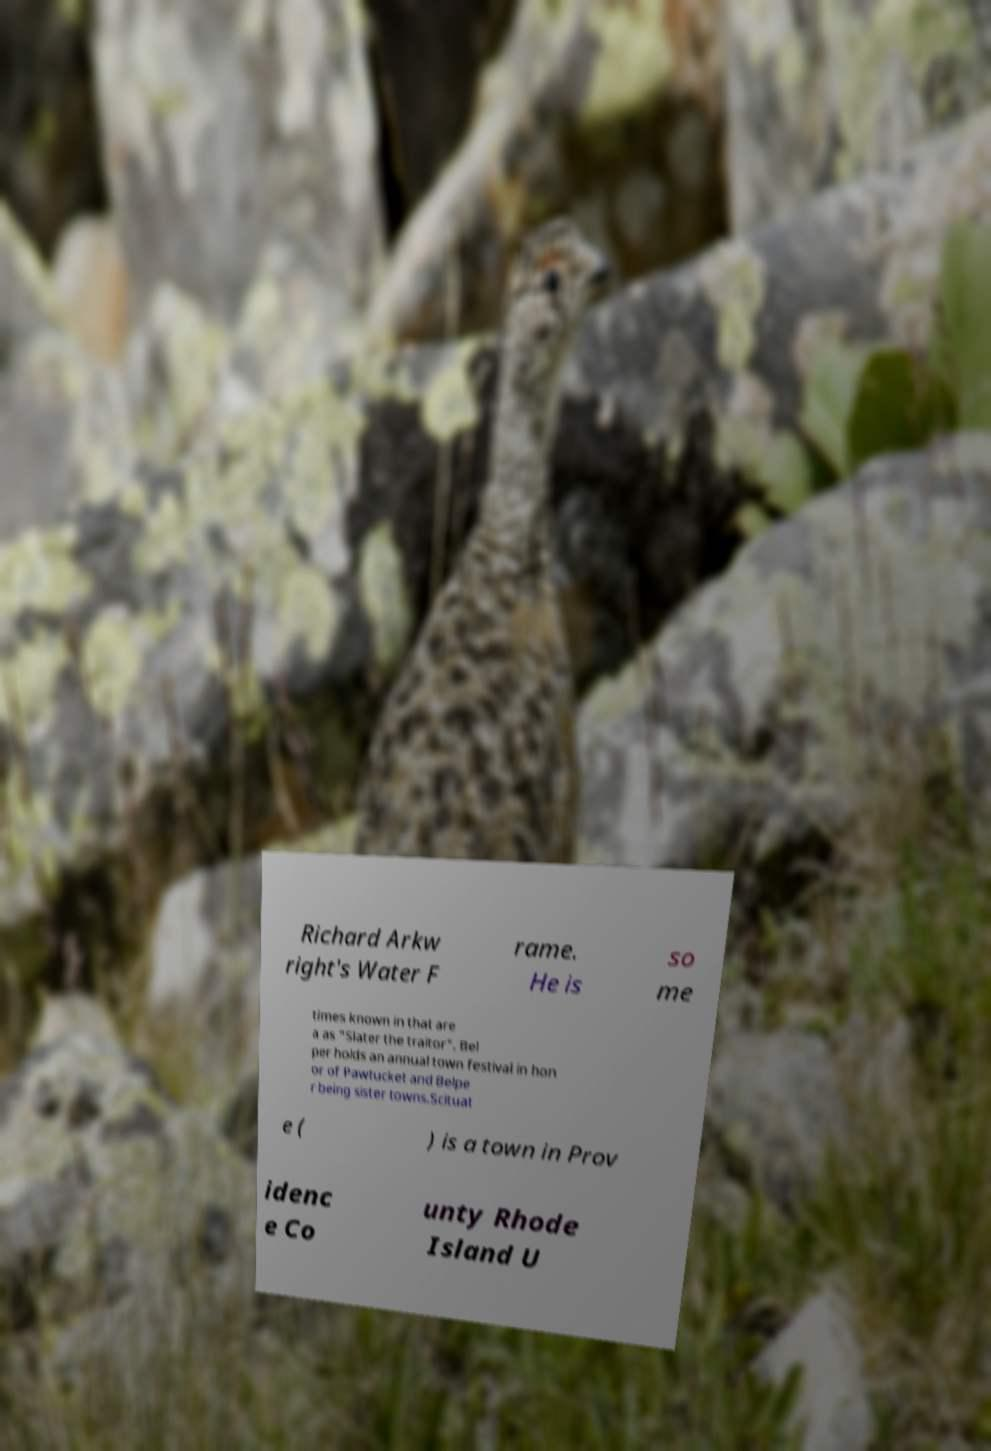Can you accurately transcribe the text from the provided image for me? Richard Arkw right's Water F rame. He is so me times known in that are a as "Slater the traitor". Bel per holds an annual town festival in hon or of Pawtucket and Belpe r being sister towns.Scituat e ( ) is a town in Prov idenc e Co unty Rhode Island U 